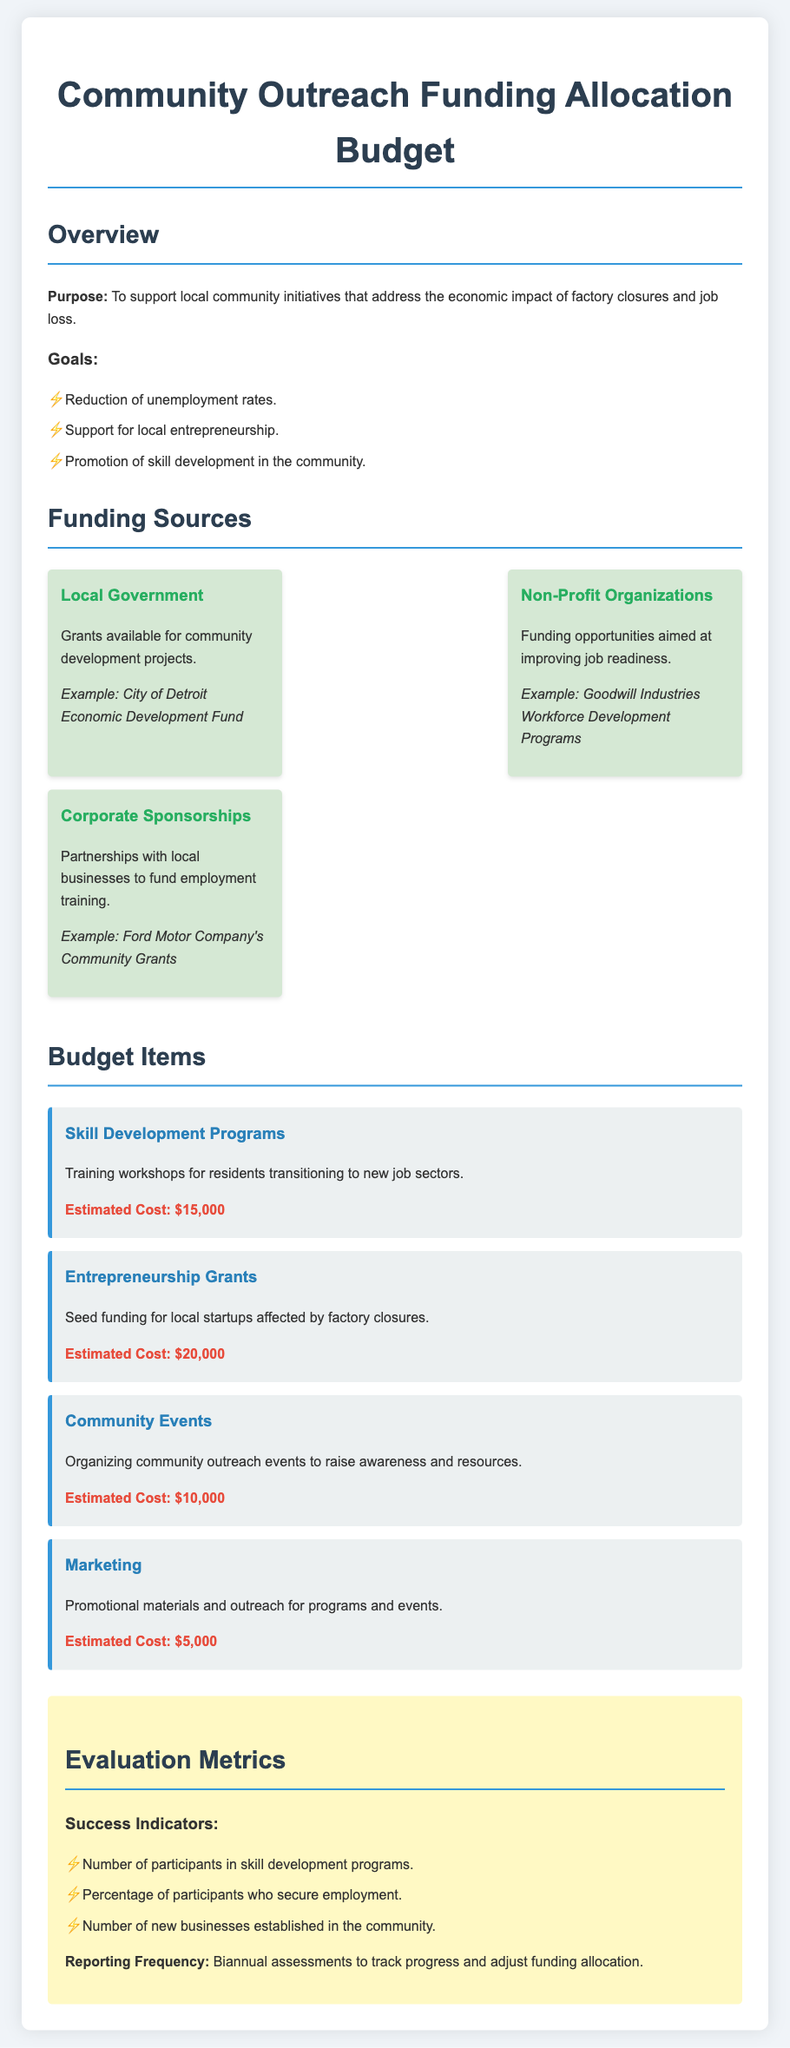what is the total estimated cost for Skill Development Programs? The document states that the estimated cost for Skill Development Programs is $15,000.
Answer: $15,000 what are the three goals listed in the budget? The goals listed are Reduction of unemployment rates, Support for local entrepreneurship, and Promotion of skill development in the community.
Answer: Reduction of unemployment rates, Support for local entrepreneurship, Promotion of skill development in the community which organization provides grants for community development projects? The document mentions the Local Government as a source of grants for community development projects.
Answer: Local Government how much funding is allocated for Community Events? The budget item for Community Events states an estimated cost of $10,000.
Answer: $10,000 which success indicator relates to employment? The success indicator that relates to employment is the Percentage of participants who secure employment.
Answer: Percentage of participants who secure employment how often will progress reports be assessed? The document specifies that progress reports will be assessed biannually.
Answer: Biannual 